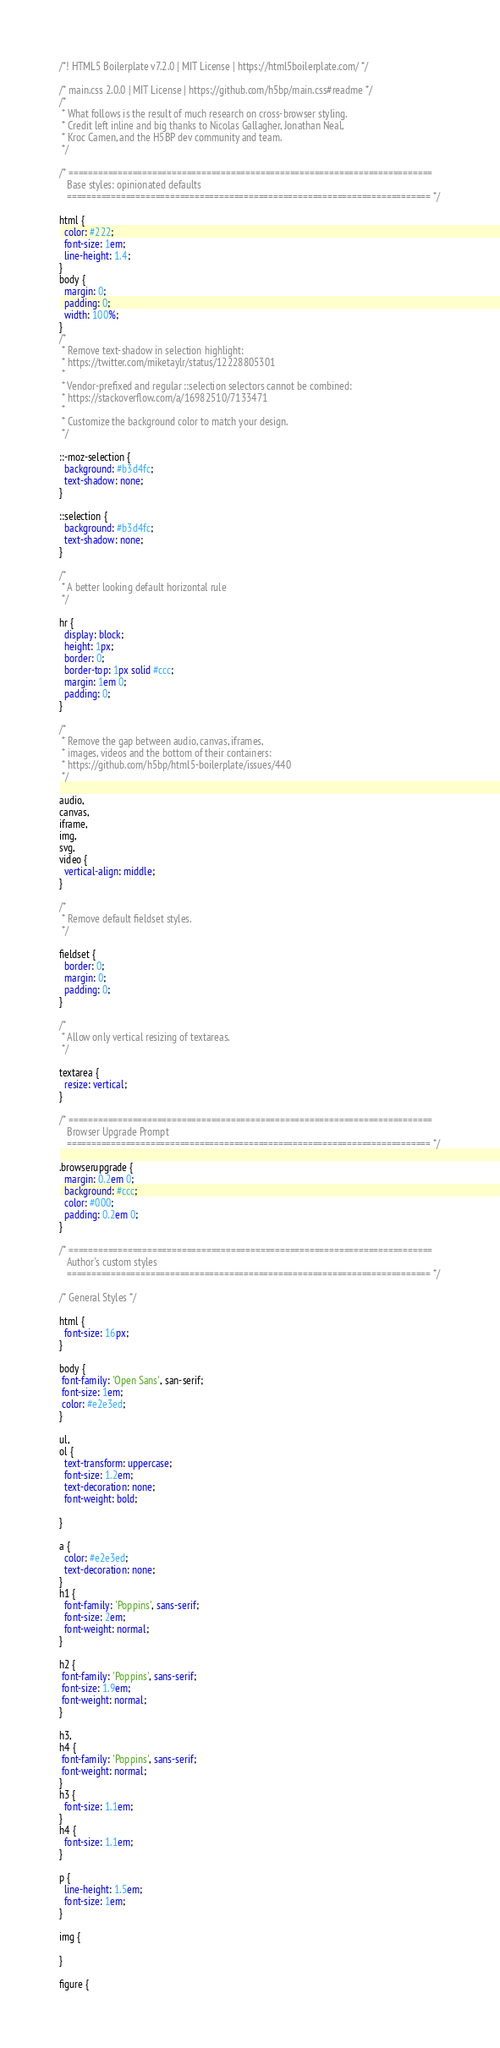<code> <loc_0><loc_0><loc_500><loc_500><_CSS_>/*! HTML5 Boilerplate v7.2.0 | MIT License | https://html5boilerplate.com/ */

/* main.css 2.0.0 | MIT License | https://github.com/h5bp/main.css#readme */
/*
 * What follows is the result of much research on cross-browser styling.
 * Credit left inline and big thanks to Nicolas Gallagher, Jonathan Neal,
 * Kroc Camen, and the H5BP dev community and team.
 */

/* ==========================================================================
   Base styles: opinionated defaults
   ========================================================================== */

html {
  color: #222;
  font-size: 1em;
  line-height: 1.4;
}
body {
  margin: 0;
  padding: 0;
  width: 100%;
}
/*
 * Remove text-shadow in selection highlight:
 * https://twitter.com/miketaylr/status/12228805301
 *
 * Vendor-prefixed and regular ::selection selectors cannot be combined:
 * https://stackoverflow.com/a/16982510/7133471
 *
 * Customize the background color to match your design.
 */

::-moz-selection {
  background: #b3d4fc;
  text-shadow: none;
}

::selection {
  background: #b3d4fc;
  text-shadow: none;
}

/*
 * A better looking default horizontal rule
 */

hr {
  display: block;
  height: 1px;
  border: 0;
  border-top: 1px solid #ccc;
  margin: 1em 0;
  padding: 0;
}

/*
 * Remove the gap between audio, canvas, iframes,
 * images, videos and the bottom of their containers:
 * https://github.com/h5bp/html5-boilerplate/issues/440
 */

audio,
canvas,
iframe,
img,
svg,
video {
  vertical-align: middle;
}

/*
 * Remove default fieldset styles.
 */

fieldset {
  border: 0;
  margin: 0;
  padding: 0;
}

/*
 * Allow only vertical resizing of textareas.
 */

textarea {
  resize: vertical;
}

/* ==========================================================================
   Browser Upgrade Prompt
   ========================================================================== */

.browserupgrade {
  margin: 0.2em 0;
  background: #ccc;
  color: #000;
  padding: 0.2em 0;
}

/* ==========================================================================
   Author's custom styles
   ========================================================================== */

/* General Styles */
 
html {
  font-size: 16px;
}
 
body {
 font-family: 'Open Sans', san-serif;
 font-size: 1em;
 color: #e2e3ed;
}
 
ul, 
ol {
  text-transform: uppercase;
  font-size: 1.2em;
  text-decoration: none;
  font-weight: bold;
 
}
 
a {
  color: #e2e3ed;
  text-decoration: none;
}
h1 {
  font-family: 'Poppins', sans-serif;
  font-size: 2em;
  font-weight: normal;
}
 
h2 {
 font-family: 'Poppins', sans-serif;
 font-size: 1.9em;
 font-weight: normal;
}
 
h3, 
h4 {
 font-family: 'Poppins', sans-serif;
 font-weight: normal;
}
h3 {
  font-size: 1.1em;
}
h4 {
  font-size: 1.1em;
}
 
p {
  line-height: 1.5em;
  font-size: 1em;
}
 
img {
 
}
 
figure {</code> 